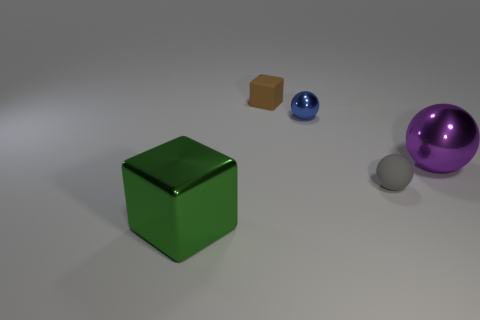What size is the brown block?
Keep it short and to the point. Small. There is a blue thing; is it the same size as the object right of the tiny gray rubber object?
Make the answer very short. No. How many brown blocks have the same material as the big green object?
Keep it short and to the point. 0. Do the blue ball and the brown object have the same size?
Provide a short and direct response. Yes. Is there anything else of the same color as the small block?
Make the answer very short. No. There is a thing that is both in front of the large ball and to the left of the small gray matte object; what is its shape?
Offer a very short reply. Cube. What is the size of the ball that is behind the big purple metal sphere?
Your answer should be very brief. Small. There is a matte thing in front of the matte object that is behind the tiny gray matte ball; what number of objects are in front of it?
Offer a terse response. 1. There is a small metal object; are there any small gray rubber things in front of it?
Make the answer very short. Yes. How many other objects are there of the same size as the matte block?
Your answer should be compact. 2. 